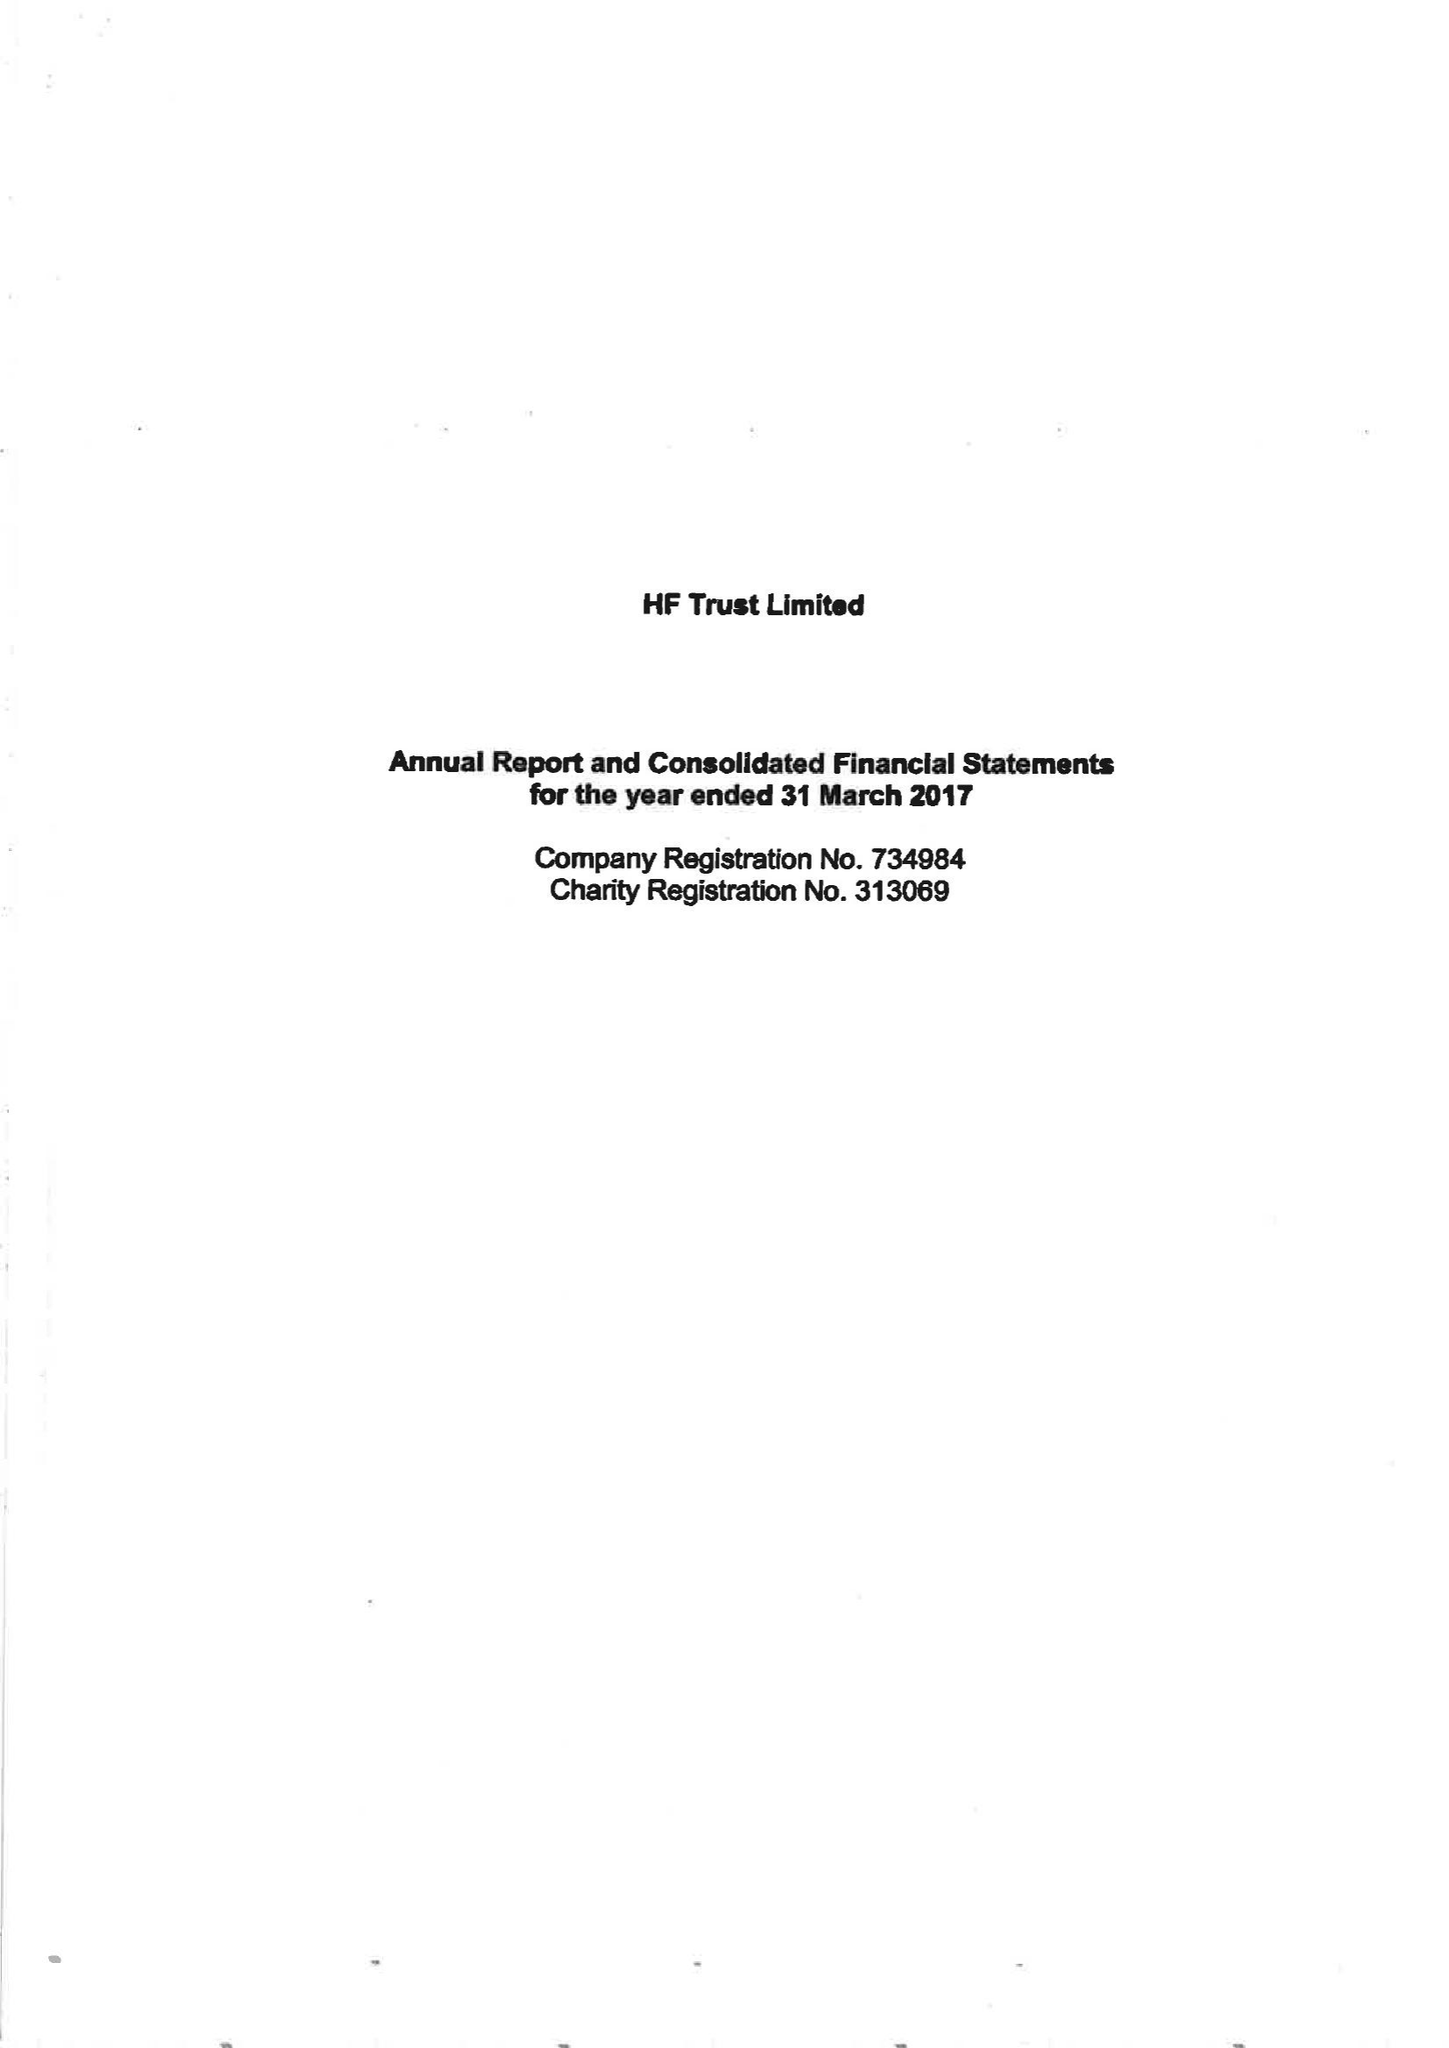What is the value for the spending_annually_in_british_pounds?
Answer the question using a single word or phrase. 80598000.00 